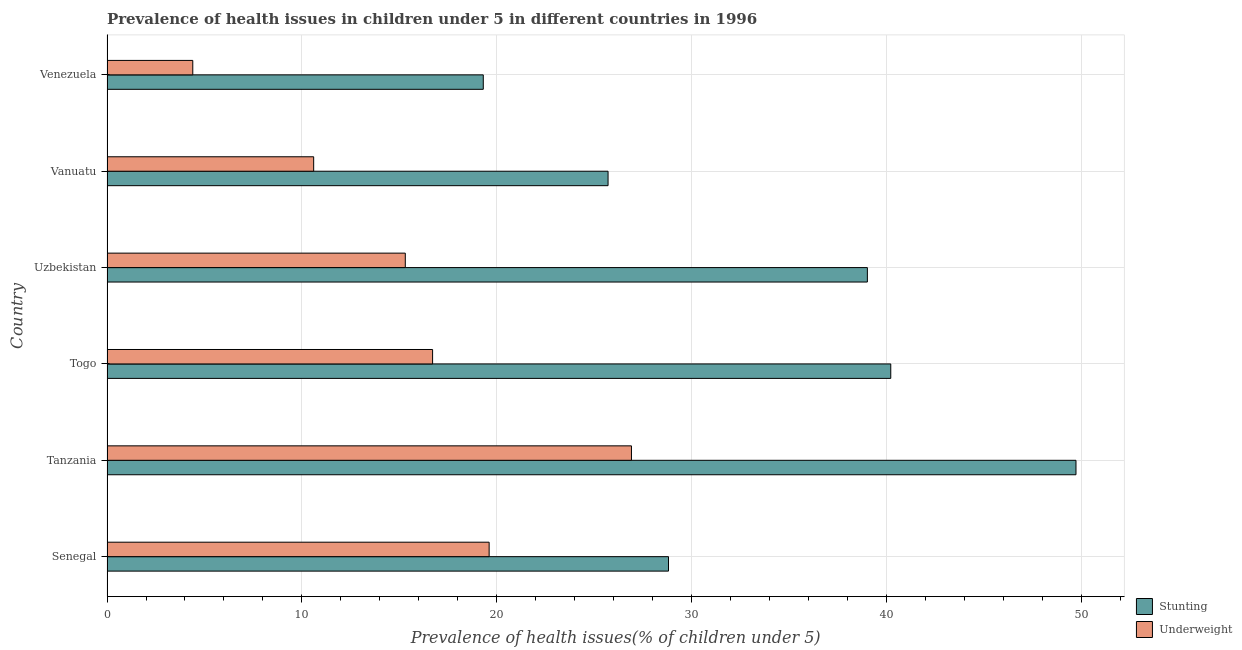How many groups of bars are there?
Offer a very short reply. 6. Are the number of bars per tick equal to the number of legend labels?
Offer a terse response. Yes. How many bars are there on the 4th tick from the bottom?
Provide a short and direct response. 2. What is the label of the 6th group of bars from the top?
Ensure brevity in your answer.  Senegal. In how many cases, is the number of bars for a given country not equal to the number of legend labels?
Provide a succinct answer. 0. What is the percentage of stunted children in Togo?
Keep it short and to the point. 40.2. Across all countries, what is the maximum percentage of underweight children?
Keep it short and to the point. 26.9. Across all countries, what is the minimum percentage of underweight children?
Offer a very short reply. 4.4. In which country was the percentage of stunted children maximum?
Keep it short and to the point. Tanzania. In which country was the percentage of underweight children minimum?
Make the answer very short. Venezuela. What is the total percentage of underweight children in the graph?
Your answer should be compact. 93.5. What is the difference between the percentage of underweight children in Togo and that in Vanuatu?
Provide a succinct answer. 6.1. What is the difference between the percentage of stunted children in Togo and the percentage of underweight children in Tanzania?
Your response must be concise. 13.3. What is the average percentage of stunted children per country?
Offer a very short reply. 33.78. What is the difference between the percentage of stunted children and percentage of underweight children in Tanzania?
Your answer should be compact. 22.8. What is the ratio of the percentage of stunted children in Tanzania to that in Uzbekistan?
Keep it short and to the point. 1.27. Is the percentage of underweight children in Vanuatu less than that in Venezuela?
Keep it short and to the point. No. What is the difference between the highest and the lowest percentage of stunted children?
Offer a terse response. 30.4. Is the sum of the percentage of stunted children in Senegal and Tanzania greater than the maximum percentage of underweight children across all countries?
Give a very brief answer. Yes. What does the 1st bar from the top in Vanuatu represents?
Provide a succinct answer. Underweight. What does the 2nd bar from the bottom in Senegal represents?
Ensure brevity in your answer.  Underweight. How many bars are there?
Your answer should be compact. 12. Are all the bars in the graph horizontal?
Offer a very short reply. Yes. How many countries are there in the graph?
Offer a very short reply. 6. What is the difference between two consecutive major ticks on the X-axis?
Your response must be concise. 10. Are the values on the major ticks of X-axis written in scientific E-notation?
Keep it short and to the point. No. Does the graph contain any zero values?
Give a very brief answer. No. How are the legend labels stacked?
Provide a short and direct response. Vertical. What is the title of the graph?
Make the answer very short. Prevalence of health issues in children under 5 in different countries in 1996. Does "Commercial service imports" appear as one of the legend labels in the graph?
Provide a short and direct response. No. What is the label or title of the X-axis?
Offer a terse response. Prevalence of health issues(% of children under 5). What is the Prevalence of health issues(% of children under 5) in Stunting in Senegal?
Give a very brief answer. 28.8. What is the Prevalence of health issues(% of children under 5) in Underweight in Senegal?
Your response must be concise. 19.6. What is the Prevalence of health issues(% of children under 5) in Stunting in Tanzania?
Ensure brevity in your answer.  49.7. What is the Prevalence of health issues(% of children under 5) in Underweight in Tanzania?
Your response must be concise. 26.9. What is the Prevalence of health issues(% of children under 5) in Stunting in Togo?
Your response must be concise. 40.2. What is the Prevalence of health issues(% of children under 5) of Underweight in Togo?
Give a very brief answer. 16.7. What is the Prevalence of health issues(% of children under 5) in Underweight in Uzbekistan?
Make the answer very short. 15.3. What is the Prevalence of health issues(% of children under 5) in Stunting in Vanuatu?
Your answer should be compact. 25.7. What is the Prevalence of health issues(% of children under 5) of Underweight in Vanuatu?
Your response must be concise. 10.6. What is the Prevalence of health issues(% of children under 5) in Stunting in Venezuela?
Give a very brief answer. 19.3. What is the Prevalence of health issues(% of children under 5) of Underweight in Venezuela?
Offer a terse response. 4.4. Across all countries, what is the maximum Prevalence of health issues(% of children under 5) in Stunting?
Offer a very short reply. 49.7. Across all countries, what is the maximum Prevalence of health issues(% of children under 5) of Underweight?
Your answer should be very brief. 26.9. Across all countries, what is the minimum Prevalence of health issues(% of children under 5) in Stunting?
Ensure brevity in your answer.  19.3. Across all countries, what is the minimum Prevalence of health issues(% of children under 5) of Underweight?
Provide a short and direct response. 4.4. What is the total Prevalence of health issues(% of children under 5) of Stunting in the graph?
Your response must be concise. 202.7. What is the total Prevalence of health issues(% of children under 5) of Underweight in the graph?
Give a very brief answer. 93.5. What is the difference between the Prevalence of health issues(% of children under 5) of Stunting in Senegal and that in Tanzania?
Your answer should be very brief. -20.9. What is the difference between the Prevalence of health issues(% of children under 5) in Underweight in Senegal and that in Tanzania?
Your response must be concise. -7.3. What is the difference between the Prevalence of health issues(% of children under 5) in Stunting in Senegal and that in Vanuatu?
Your answer should be compact. 3.1. What is the difference between the Prevalence of health issues(% of children under 5) of Underweight in Senegal and that in Vanuatu?
Offer a terse response. 9. What is the difference between the Prevalence of health issues(% of children under 5) of Stunting in Senegal and that in Venezuela?
Your response must be concise. 9.5. What is the difference between the Prevalence of health issues(% of children under 5) in Stunting in Tanzania and that in Togo?
Make the answer very short. 9.5. What is the difference between the Prevalence of health issues(% of children under 5) of Underweight in Tanzania and that in Togo?
Provide a succinct answer. 10.2. What is the difference between the Prevalence of health issues(% of children under 5) in Stunting in Tanzania and that in Uzbekistan?
Offer a very short reply. 10.7. What is the difference between the Prevalence of health issues(% of children under 5) of Underweight in Tanzania and that in Uzbekistan?
Provide a short and direct response. 11.6. What is the difference between the Prevalence of health issues(% of children under 5) of Stunting in Tanzania and that in Venezuela?
Offer a very short reply. 30.4. What is the difference between the Prevalence of health issues(% of children under 5) in Stunting in Togo and that in Uzbekistan?
Your answer should be compact. 1.2. What is the difference between the Prevalence of health issues(% of children under 5) in Underweight in Togo and that in Uzbekistan?
Your answer should be compact. 1.4. What is the difference between the Prevalence of health issues(% of children under 5) in Underweight in Togo and that in Vanuatu?
Your response must be concise. 6.1. What is the difference between the Prevalence of health issues(% of children under 5) in Stunting in Togo and that in Venezuela?
Offer a very short reply. 20.9. What is the difference between the Prevalence of health issues(% of children under 5) of Stunting in Uzbekistan and that in Vanuatu?
Provide a short and direct response. 13.3. What is the difference between the Prevalence of health issues(% of children under 5) in Underweight in Uzbekistan and that in Venezuela?
Make the answer very short. 10.9. What is the difference between the Prevalence of health issues(% of children under 5) in Underweight in Vanuatu and that in Venezuela?
Offer a terse response. 6.2. What is the difference between the Prevalence of health issues(% of children under 5) in Stunting in Senegal and the Prevalence of health issues(% of children under 5) in Underweight in Venezuela?
Keep it short and to the point. 24.4. What is the difference between the Prevalence of health issues(% of children under 5) of Stunting in Tanzania and the Prevalence of health issues(% of children under 5) of Underweight in Togo?
Offer a very short reply. 33. What is the difference between the Prevalence of health issues(% of children under 5) of Stunting in Tanzania and the Prevalence of health issues(% of children under 5) of Underweight in Uzbekistan?
Give a very brief answer. 34.4. What is the difference between the Prevalence of health issues(% of children under 5) of Stunting in Tanzania and the Prevalence of health issues(% of children under 5) of Underweight in Vanuatu?
Provide a short and direct response. 39.1. What is the difference between the Prevalence of health issues(% of children under 5) in Stunting in Tanzania and the Prevalence of health issues(% of children under 5) in Underweight in Venezuela?
Make the answer very short. 45.3. What is the difference between the Prevalence of health issues(% of children under 5) in Stunting in Togo and the Prevalence of health issues(% of children under 5) in Underweight in Uzbekistan?
Ensure brevity in your answer.  24.9. What is the difference between the Prevalence of health issues(% of children under 5) of Stunting in Togo and the Prevalence of health issues(% of children under 5) of Underweight in Vanuatu?
Make the answer very short. 29.6. What is the difference between the Prevalence of health issues(% of children under 5) in Stunting in Togo and the Prevalence of health issues(% of children under 5) in Underweight in Venezuela?
Ensure brevity in your answer.  35.8. What is the difference between the Prevalence of health issues(% of children under 5) of Stunting in Uzbekistan and the Prevalence of health issues(% of children under 5) of Underweight in Vanuatu?
Your response must be concise. 28.4. What is the difference between the Prevalence of health issues(% of children under 5) of Stunting in Uzbekistan and the Prevalence of health issues(% of children under 5) of Underweight in Venezuela?
Make the answer very short. 34.6. What is the difference between the Prevalence of health issues(% of children under 5) of Stunting in Vanuatu and the Prevalence of health issues(% of children under 5) of Underweight in Venezuela?
Make the answer very short. 21.3. What is the average Prevalence of health issues(% of children under 5) in Stunting per country?
Offer a very short reply. 33.78. What is the average Prevalence of health issues(% of children under 5) in Underweight per country?
Offer a very short reply. 15.58. What is the difference between the Prevalence of health issues(% of children under 5) of Stunting and Prevalence of health issues(% of children under 5) of Underweight in Senegal?
Ensure brevity in your answer.  9.2. What is the difference between the Prevalence of health issues(% of children under 5) in Stunting and Prevalence of health issues(% of children under 5) in Underweight in Tanzania?
Provide a succinct answer. 22.8. What is the difference between the Prevalence of health issues(% of children under 5) in Stunting and Prevalence of health issues(% of children under 5) in Underweight in Togo?
Ensure brevity in your answer.  23.5. What is the difference between the Prevalence of health issues(% of children under 5) in Stunting and Prevalence of health issues(% of children under 5) in Underweight in Uzbekistan?
Your answer should be very brief. 23.7. What is the difference between the Prevalence of health issues(% of children under 5) in Stunting and Prevalence of health issues(% of children under 5) in Underweight in Vanuatu?
Your answer should be very brief. 15.1. What is the difference between the Prevalence of health issues(% of children under 5) of Stunting and Prevalence of health issues(% of children under 5) of Underweight in Venezuela?
Provide a short and direct response. 14.9. What is the ratio of the Prevalence of health issues(% of children under 5) of Stunting in Senegal to that in Tanzania?
Give a very brief answer. 0.58. What is the ratio of the Prevalence of health issues(% of children under 5) in Underweight in Senegal to that in Tanzania?
Provide a short and direct response. 0.73. What is the ratio of the Prevalence of health issues(% of children under 5) in Stunting in Senegal to that in Togo?
Provide a succinct answer. 0.72. What is the ratio of the Prevalence of health issues(% of children under 5) in Underweight in Senegal to that in Togo?
Make the answer very short. 1.17. What is the ratio of the Prevalence of health issues(% of children under 5) in Stunting in Senegal to that in Uzbekistan?
Offer a terse response. 0.74. What is the ratio of the Prevalence of health issues(% of children under 5) in Underweight in Senegal to that in Uzbekistan?
Make the answer very short. 1.28. What is the ratio of the Prevalence of health issues(% of children under 5) of Stunting in Senegal to that in Vanuatu?
Offer a terse response. 1.12. What is the ratio of the Prevalence of health issues(% of children under 5) of Underweight in Senegal to that in Vanuatu?
Ensure brevity in your answer.  1.85. What is the ratio of the Prevalence of health issues(% of children under 5) of Stunting in Senegal to that in Venezuela?
Ensure brevity in your answer.  1.49. What is the ratio of the Prevalence of health issues(% of children under 5) of Underweight in Senegal to that in Venezuela?
Give a very brief answer. 4.45. What is the ratio of the Prevalence of health issues(% of children under 5) of Stunting in Tanzania to that in Togo?
Your answer should be compact. 1.24. What is the ratio of the Prevalence of health issues(% of children under 5) of Underweight in Tanzania to that in Togo?
Your answer should be very brief. 1.61. What is the ratio of the Prevalence of health issues(% of children under 5) in Stunting in Tanzania to that in Uzbekistan?
Make the answer very short. 1.27. What is the ratio of the Prevalence of health issues(% of children under 5) in Underweight in Tanzania to that in Uzbekistan?
Provide a succinct answer. 1.76. What is the ratio of the Prevalence of health issues(% of children under 5) in Stunting in Tanzania to that in Vanuatu?
Provide a short and direct response. 1.93. What is the ratio of the Prevalence of health issues(% of children under 5) of Underweight in Tanzania to that in Vanuatu?
Give a very brief answer. 2.54. What is the ratio of the Prevalence of health issues(% of children under 5) of Stunting in Tanzania to that in Venezuela?
Offer a very short reply. 2.58. What is the ratio of the Prevalence of health issues(% of children under 5) in Underweight in Tanzania to that in Venezuela?
Offer a very short reply. 6.11. What is the ratio of the Prevalence of health issues(% of children under 5) in Stunting in Togo to that in Uzbekistan?
Offer a terse response. 1.03. What is the ratio of the Prevalence of health issues(% of children under 5) of Underweight in Togo to that in Uzbekistan?
Keep it short and to the point. 1.09. What is the ratio of the Prevalence of health issues(% of children under 5) of Stunting in Togo to that in Vanuatu?
Provide a short and direct response. 1.56. What is the ratio of the Prevalence of health issues(% of children under 5) of Underweight in Togo to that in Vanuatu?
Ensure brevity in your answer.  1.58. What is the ratio of the Prevalence of health issues(% of children under 5) of Stunting in Togo to that in Venezuela?
Your answer should be very brief. 2.08. What is the ratio of the Prevalence of health issues(% of children under 5) in Underweight in Togo to that in Venezuela?
Keep it short and to the point. 3.8. What is the ratio of the Prevalence of health issues(% of children under 5) of Stunting in Uzbekistan to that in Vanuatu?
Your answer should be very brief. 1.52. What is the ratio of the Prevalence of health issues(% of children under 5) of Underweight in Uzbekistan to that in Vanuatu?
Make the answer very short. 1.44. What is the ratio of the Prevalence of health issues(% of children under 5) in Stunting in Uzbekistan to that in Venezuela?
Your response must be concise. 2.02. What is the ratio of the Prevalence of health issues(% of children under 5) in Underweight in Uzbekistan to that in Venezuela?
Give a very brief answer. 3.48. What is the ratio of the Prevalence of health issues(% of children under 5) of Stunting in Vanuatu to that in Venezuela?
Keep it short and to the point. 1.33. What is the ratio of the Prevalence of health issues(% of children under 5) in Underweight in Vanuatu to that in Venezuela?
Keep it short and to the point. 2.41. What is the difference between the highest and the second highest Prevalence of health issues(% of children under 5) in Stunting?
Provide a succinct answer. 9.5. What is the difference between the highest and the lowest Prevalence of health issues(% of children under 5) in Stunting?
Ensure brevity in your answer.  30.4. What is the difference between the highest and the lowest Prevalence of health issues(% of children under 5) in Underweight?
Make the answer very short. 22.5. 